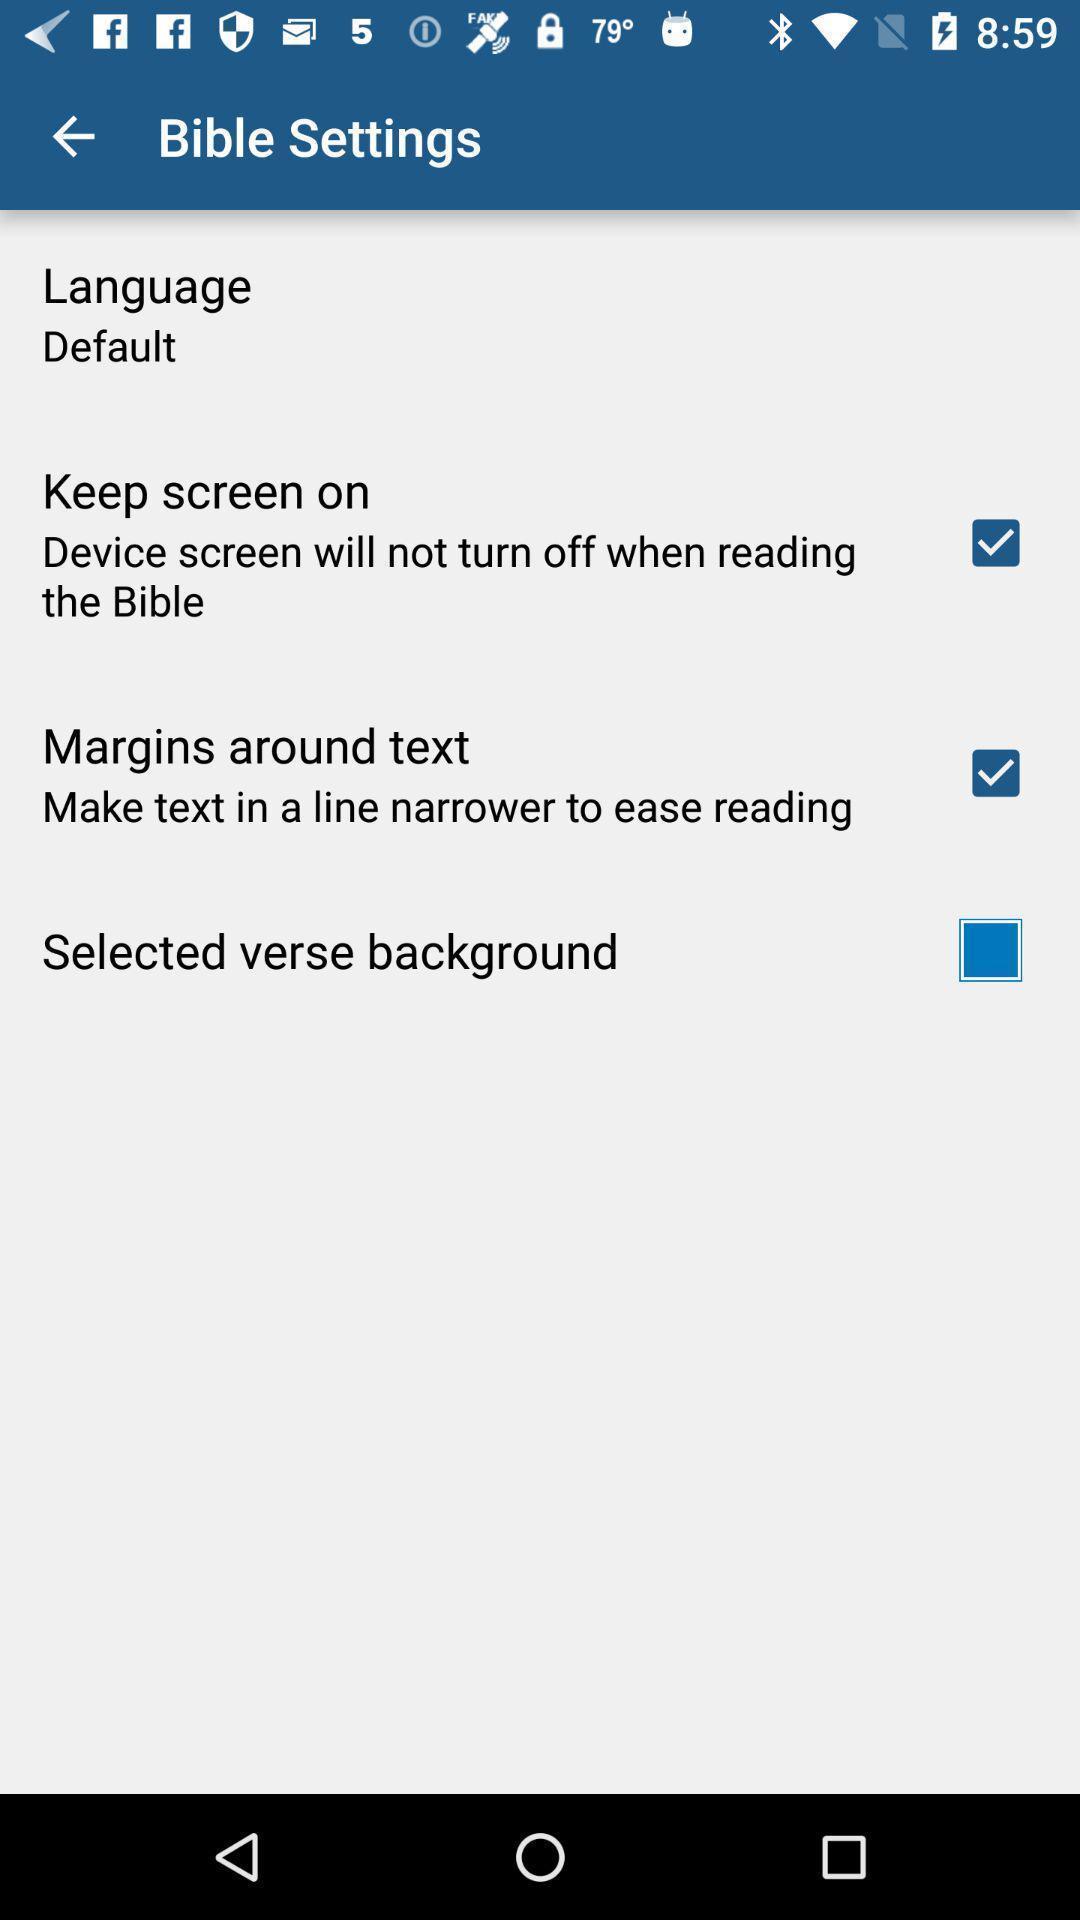Tell me about the visual elements in this screen capture. Settings page of a holy book app. 